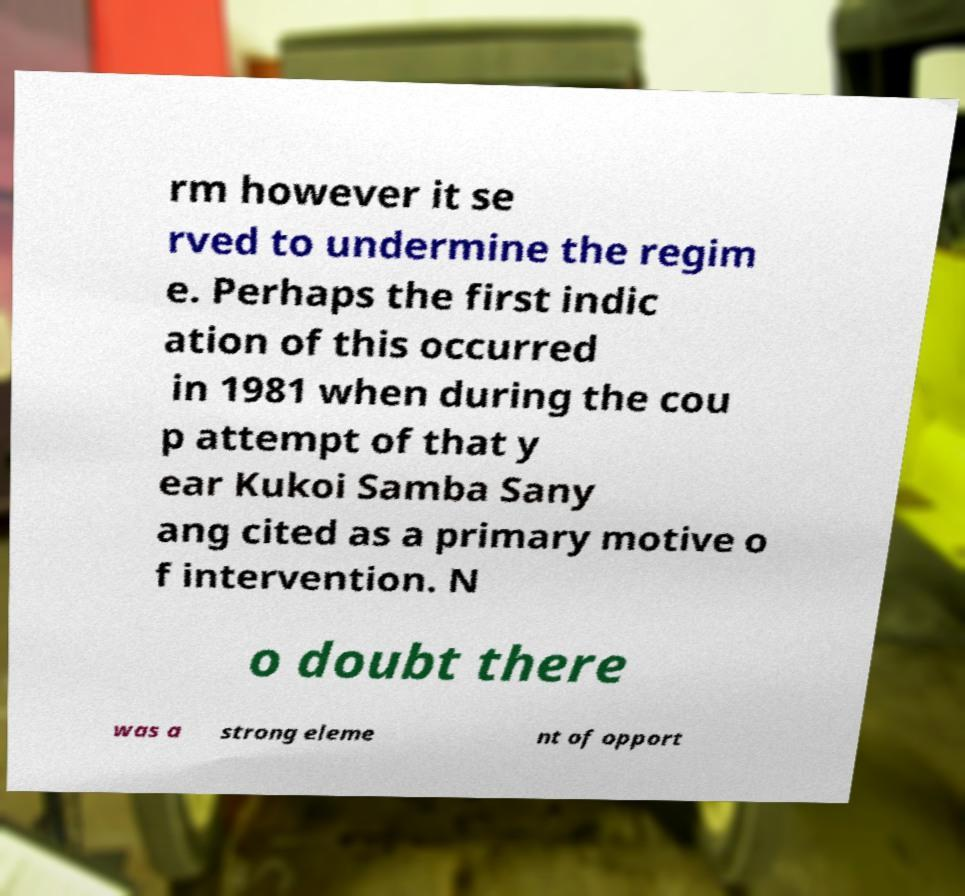What messages or text are displayed in this image? I need them in a readable, typed format. rm however it se rved to undermine the regim e. Perhaps the first indic ation of this occurred in 1981 when during the cou p attempt of that y ear Kukoi Samba Sany ang cited as a primary motive o f intervention. N o doubt there was a strong eleme nt of opport 